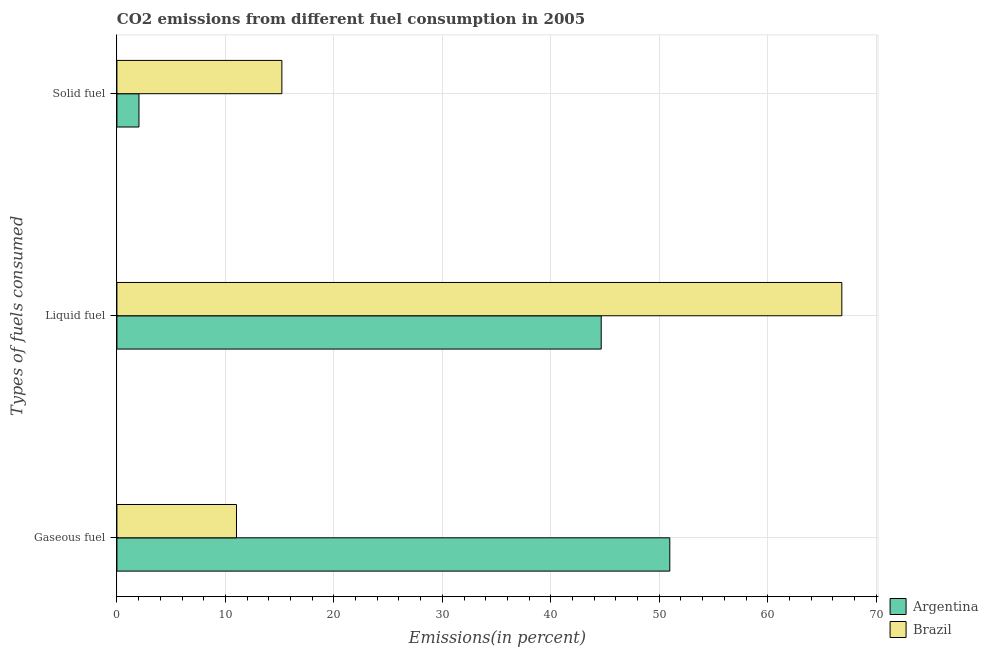How many groups of bars are there?
Provide a succinct answer. 3. How many bars are there on the 2nd tick from the top?
Your answer should be compact. 2. How many bars are there on the 1st tick from the bottom?
Make the answer very short. 2. What is the label of the 2nd group of bars from the top?
Your response must be concise. Liquid fuel. What is the percentage of solid fuel emission in Argentina?
Keep it short and to the point. 2.03. Across all countries, what is the maximum percentage of gaseous fuel emission?
Ensure brevity in your answer.  50.97. Across all countries, what is the minimum percentage of liquid fuel emission?
Provide a short and direct response. 44.65. In which country was the percentage of solid fuel emission maximum?
Keep it short and to the point. Brazil. In which country was the percentage of liquid fuel emission minimum?
Offer a very short reply. Argentina. What is the total percentage of gaseous fuel emission in the graph?
Offer a terse response. 61.99. What is the difference between the percentage of liquid fuel emission in Argentina and that in Brazil?
Your answer should be compact. -22.18. What is the difference between the percentage of gaseous fuel emission in Argentina and the percentage of solid fuel emission in Brazil?
Make the answer very short. 35.76. What is the average percentage of gaseous fuel emission per country?
Your answer should be compact. 31. What is the difference between the percentage of gaseous fuel emission and percentage of solid fuel emission in Brazil?
Your response must be concise. -4.19. What is the ratio of the percentage of gaseous fuel emission in Argentina to that in Brazil?
Give a very brief answer. 4.62. What is the difference between the highest and the second highest percentage of solid fuel emission?
Give a very brief answer. 13.17. What is the difference between the highest and the lowest percentage of solid fuel emission?
Provide a short and direct response. 13.17. In how many countries, is the percentage of gaseous fuel emission greater than the average percentage of gaseous fuel emission taken over all countries?
Provide a succinct answer. 1. Is the sum of the percentage of liquid fuel emission in Brazil and Argentina greater than the maximum percentage of gaseous fuel emission across all countries?
Your answer should be compact. Yes. What does the 2nd bar from the bottom in Solid fuel represents?
Your response must be concise. Brazil. Is it the case that in every country, the sum of the percentage of gaseous fuel emission and percentage of liquid fuel emission is greater than the percentage of solid fuel emission?
Offer a very short reply. Yes. How many countries are there in the graph?
Provide a succinct answer. 2. What is the difference between two consecutive major ticks on the X-axis?
Give a very brief answer. 10. How many legend labels are there?
Offer a very short reply. 2. How are the legend labels stacked?
Ensure brevity in your answer.  Vertical. What is the title of the graph?
Keep it short and to the point. CO2 emissions from different fuel consumption in 2005. What is the label or title of the X-axis?
Make the answer very short. Emissions(in percent). What is the label or title of the Y-axis?
Give a very brief answer. Types of fuels consumed. What is the Emissions(in percent) in Argentina in Gaseous fuel?
Offer a terse response. 50.97. What is the Emissions(in percent) in Brazil in Gaseous fuel?
Keep it short and to the point. 11.02. What is the Emissions(in percent) of Argentina in Liquid fuel?
Ensure brevity in your answer.  44.65. What is the Emissions(in percent) of Brazil in Liquid fuel?
Ensure brevity in your answer.  66.83. What is the Emissions(in percent) in Argentina in Solid fuel?
Your answer should be compact. 2.03. What is the Emissions(in percent) in Brazil in Solid fuel?
Ensure brevity in your answer.  15.21. Across all Types of fuels consumed, what is the maximum Emissions(in percent) of Argentina?
Offer a very short reply. 50.97. Across all Types of fuels consumed, what is the maximum Emissions(in percent) in Brazil?
Give a very brief answer. 66.83. Across all Types of fuels consumed, what is the minimum Emissions(in percent) in Argentina?
Your answer should be compact. 2.03. Across all Types of fuels consumed, what is the minimum Emissions(in percent) of Brazil?
Give a very brief answer. 11.02. What is the total Emissions(in percent) of Argentina in the graph?
Offer a very short reply. 97.65. What is the total Emissions(in percent) of Brazil in the graph?
Offer a very short reply. 93.06. What is the difference between the Emissions(in percent) in Argentina in Gaseous fuel and that in Liquid fuel?
Your answer should be compact. 6.32. What is the difference between the Emissions(in percent) in Brazil in Gaseous fuel and that in Liquid fuel?
Ensure brevity in your answer.  -55.81. What is the difference between the Emissions(in percent) in Argentina in Gaseous fuel and that in Solid fuel?
Your answer should be very brief. 48.94. What is the difference between the Emissions(in percent) in Brazil in Gaseous fuel and that in Solid fuel?
Offer a very short reply. -4.19. What is the difference between the Emissions(in percent) in Argentina in Liquid fuel and that in Solid fuel?
Provide a short and direct response. 42.61. What is the difference between the Emissions(in percent) of Brazil in Liquid fuel and that in Solid fuel?
Your answer should be compact. 51.62. What is the difference between the Emissions(in percent) of Argentina in Gaseous fuel and the Emissions(in percent) of Brazil in Liquid fuel?
Your answer should be very brief. -15.86. What is the difference between the Emissions(in percent) of Argentina in Gaseous fuel and the Emissions(in percent) of Brazil in Solid fuel?
Keep it short and to the point. 35.76. What is the difference between the Emissions(in percent) in Argentina in Liquid fuel and the Emissions(in percent) in Brazil in Solid fuel?
Your answer should be very brief. 29.44. What is the average Emissions(in percent) in Argentina per Types of fuels consumed?
Keep it short and to the point. 32.55. What is the average Emissions(in percent) of Brazil per Types of fuels consumed?
Provide a succinct answer. 31.02. What is the difference between the Emissions(in percent) of Argentina and Emissions(in percent) of Brazil in Gaseous fuel?
Make the answer very short. 39.95. What is the difference between the Emissions(in percent) in Argentina and Emissions(in percent) in Brazil in Liquid fuel?
Offer a terse response. -22.18. What is the difference between the Emissions(in percent) in Argentina and Emissions(in percent) in Brazil in Solid fuel?
Offer a terse response. -13.17. What is the ratio of the Emissions(in percent) in Argentina in Gaseous fuel to that in Liquid fuel?
Your response must be concise. 1.14. What is the ratio of the Emissions(in percent) of Brazil in Gaseous fuel to that in Liquid fuel?
Provide a short and direct response. 0.16. What is the ratio of the Emissions(in percent) of Argentina in Gaseous fuel to that in Solid fuel?
Make the answer very short. 25.08. What is the ratio of the Emissions(in percent) of Brazil in Gaseous fuel to that in Solid fuel?
Make the answer very short. 0.72. What is the ratio of the Emissions(in percent) in Argentina in Liquid fuel to that in Solid fuel?
Offer a terse response. 21.97. What is the ratio of the Emissions(in percent) of Brazil in Liquid fuel to that in Solid fuel?
Keep it short and to the point. 4.39. What is the difference between the highest and the second highest Emissions(in percent) of Argentina?
Offer a very short reply. 6.32. What is the difference between the highest and the second highest Emissions(in percent) of Brazil?
Make the answer very short. 51.62. What is the difference between the highest and the lowest Emissions(in percent) in Argentina?
Your answer should be very brief. 48.94. What is the difference between the highest and the lowest Emissions(in percent) in Brazil?
Provide a short and direct response. 55.81. 